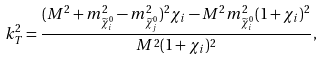<formula> <loc_0><loc_0><loc_500><loc_500>k _ { T } ^ { 2 } = \frac { ( M ^ { 2 } + m _ { \widetilde { \chi } _ { i } ^ { 0 } } ^ { 2 } - m _ { \widetilde { \chi } _ { j } ^ { 0 } } ^ { 2 } ) ^ { 2 } { \chi } _ { i } - M ^ { 2 } m _ { \widetilde { \chi } _ { i } ^ { 0 } } ^ { 2 } ( 1 + { \chi } _ { i } ) ^ { 2 } } { M ^ { 2 } ( 1 + { \chi } _ { i } ) ^ { 2 } } ,</formula> 